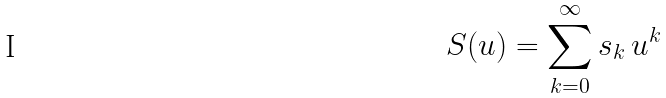Convert formula to latex. <formula><loc_0><loc_0><loc_500><loc_500>S ( u ) = \sum _ { k = 0 } ^ { \infty } s _ { k } \, u ^ { k }</formula> 